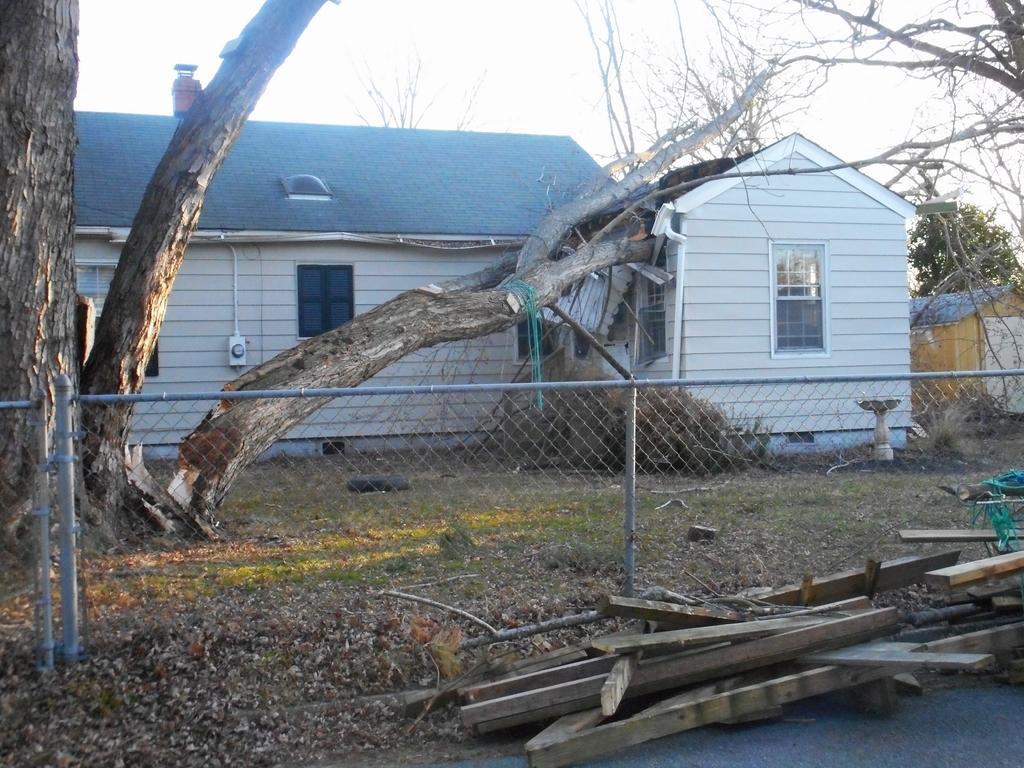Could you give a brief overview of what you see in this image? In this image I can see a house , in front of the house I can see stem of tree and and fence and wooden sticks, at the top I can see the sky. 